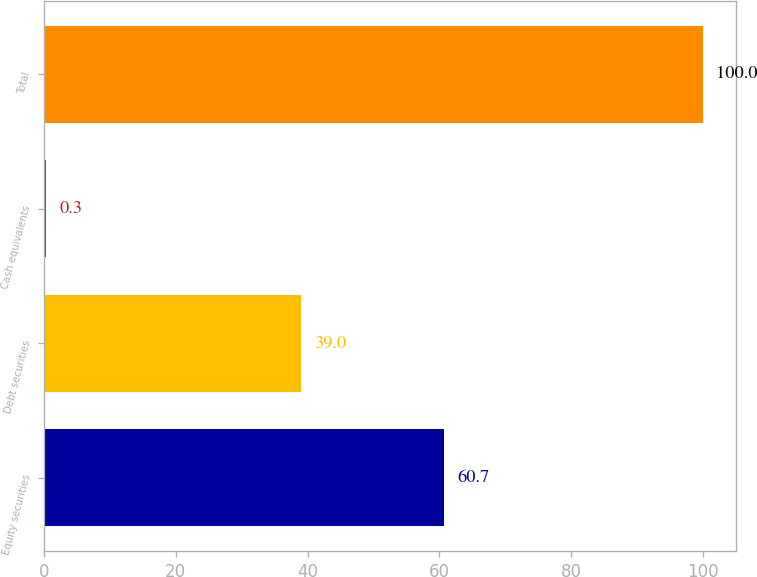Convert chart to OTSL. <chart><loc_0><loc_0><loc_500><loc_500><bar_chart><fcel>Equity securities<fcel>Debt securities<fcel>Cash equivalents<fcel>Total<nl><fcel>60.7<fcel>39<fcel>0.3<fcel>100<nl></chart> 